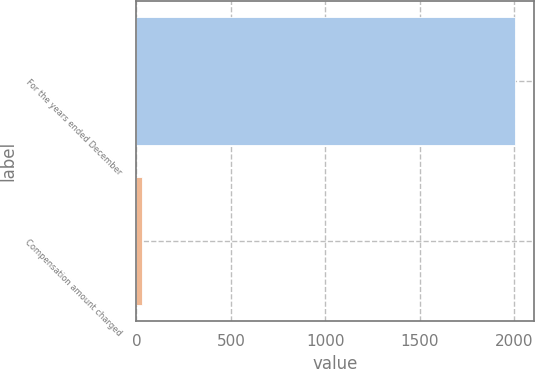<chart> <loc_0><loc_0><loc_500><loc_500><bar_chart><fcel>For the years ended December<fcel>Compensation amount charged<nl><fcel>2007<fcel>26.8<nl></chart> 